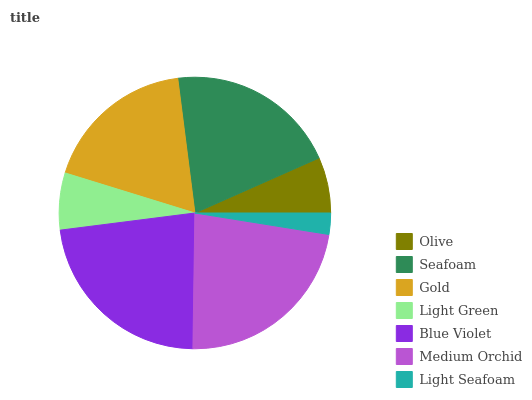Is Light Seafoam the minimum?
Answer yes or no. Yes. Is Blue Violet the maximum?
Answer yes or no. Yes. Is Seafoam the minimum?
Answer yes or no. No. Is Seafoam the maximum?
Answer yes or no. No. Is Seafoam greater than Olive?
Answer yes or no. Yes. Is Olive less than Seafoam?
Answer yes or no. Yes. Is Olive greater than Seafoam?
Answer yes or no. No. Is Seafoam less than Olive?
Answer yes or no. No. Is Gold the high median?
Answer yes or no. Yes. Is Gold the low median?
Answer yes or no. Yes. Is Medium Orchid the high median?
Answer yes or no. No. Is Olive the low median?
Answer yes or no. No. 